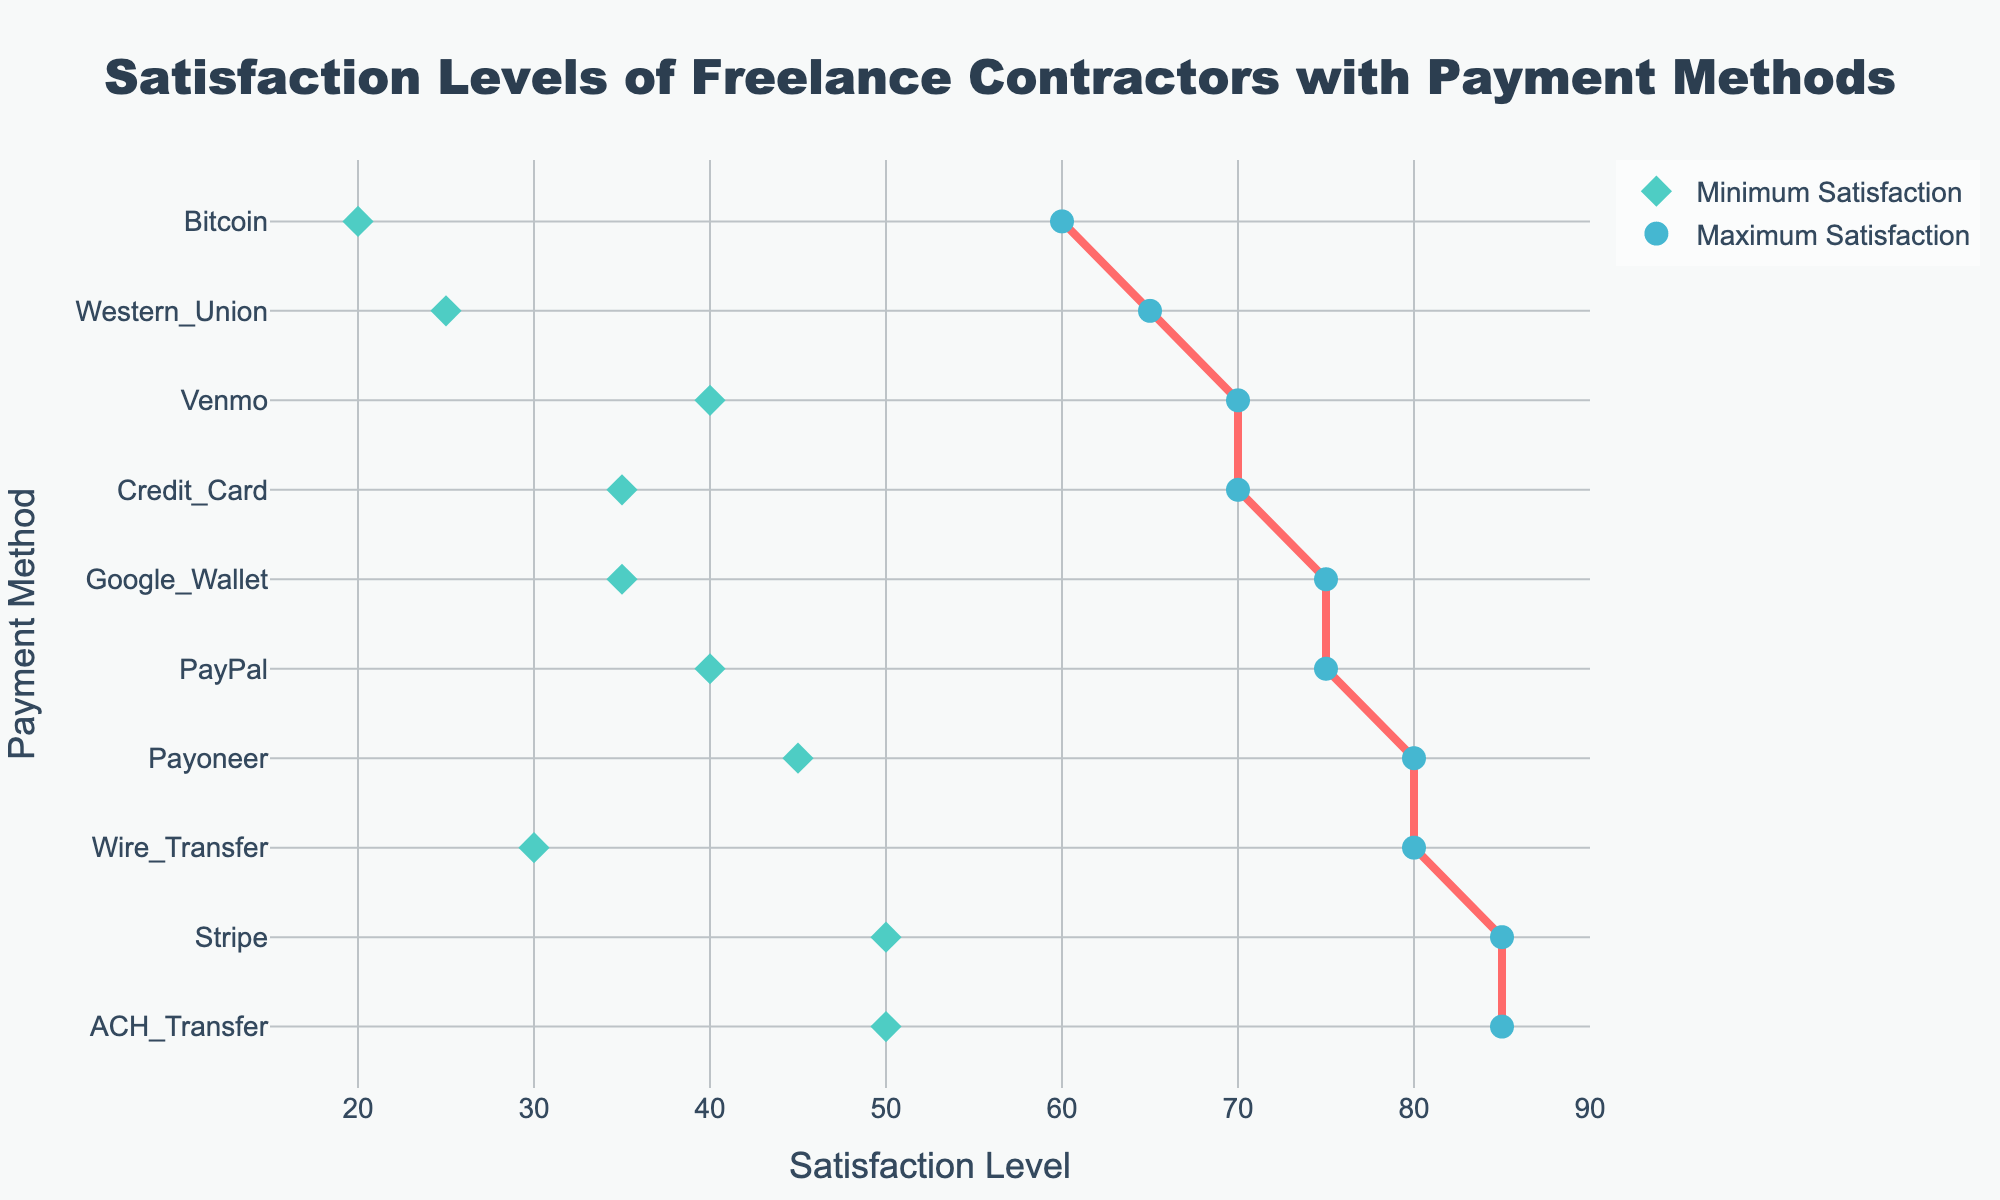What's the title of the figure? The title of the figure is usually located at the top and is often larger or in bold text to stand out. In this figure, you can see "Satisfaction Levels of Freelance Contractors with Payment Methods" at the center top.
Answer: Satisfaction Levels of Freelance Contractors with Payment Methods What are the x-axis and y-axis titles? The x-axis and y-axis titles are usually labeled near the axes to provide context. Here, the x-axis is labeled "Satisfaction Level" and the y-axis is labeled "Payment Method."
Answer: x-axis: Satisfaction Level; y-axis: Payment Method Which payment method has the highest maximum satisfaction level? To find the payment method with the highest maximum satisfaction level, you need to look for the data point with the highest value on the x-axis. According to the plot, "Stripe" and "ACH_Transfer" have the highest maximum satisfaction level at 85.
Answer: Stripe and ACH_Transfer Which payment method has the lowest minimum satisfaction level? Look for the data point with the lowest value on the x-axis for the "Minimum Satisfaction" points. According to the plot, "Bitcoin" has the lowest minimum satisfaction level at 20.
Answer: Bitcoin What is the satisfaction range for Wire Transfer? To determine the range, subtract the minimum satisfaction level from the maximum satisfaction level for Wire Transfer. The values are 80 (maximum) and 30 (minimum). So, 80 - 30 = 50.
Answer: 50 How many payment methods have a minimum satisfaction level of 40 or higher? Count the number of payment methods with minimum satisfaction levels of 40 or higher by looking at the "Minimum Satisfaction" points on the x-axis. PayPal, Payoneer, Venmo, and Stripe meet this criterion, giving a total of 4.
Answer: 4 Which payment methods have an equal maximum satisfaction level of 75? Look for data points on the x-axis with a value of 75 for "Maximum Satisfaction." According to the plot, "PayPal" and "Google_Wallet" both have a maximum satisfaction level of 75.
Answer: PayPal and Google_Wallet Which payment method shows the smallest gap between minimum and maximum satisfaction levels? To find this, calculate the gap for each method and compare. PayPal (75-40=35), Wire_Transfer (80-30=50), ACH_Transfer (85-50=35), Credit_Card (70-35=35), Bitcoin (60-20=40), Western_Union (65-25=40), Payoneer (80-45=35), Venmo (70-40=30), Google_Wallet (75-35=40), Stripe (85-50=35). Venmo has the smallest gap of 30.
Answer: Venmo 